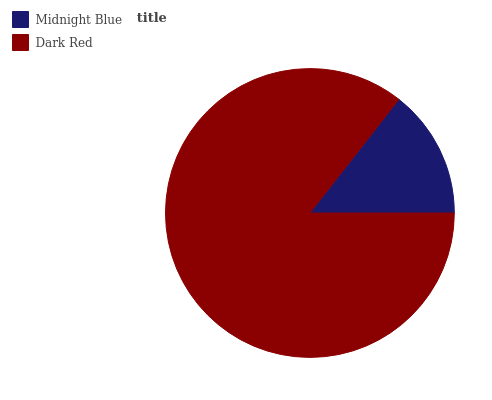Is Midnight Blue the minimum?
Answer yes or no. Yes. Is Dark Red the maximum?
Answer yes or no. Yes. Is Dark Red the minimum?
Answer yes or no. No. Is Dark Red greater than Midnight Blue?
Answer yes or no. Yes. Is Midnight Blue less than Dark Red?
Answer yes or no. Yes. Is Midnight Blue greater than Dark Red?
Answer yes or no. No. Is Dark Red less than Midnight Blue?
Answer yes or no. No. Is Dark Red the high median?
Answer yes or no. Yes. Is Midnight Blue the low median?
Answer yes or no. Yes. Is Midnight Blue the high median?
Answer yes or no. No. Is Dark Red the low median?
Answer yes or no. No. 